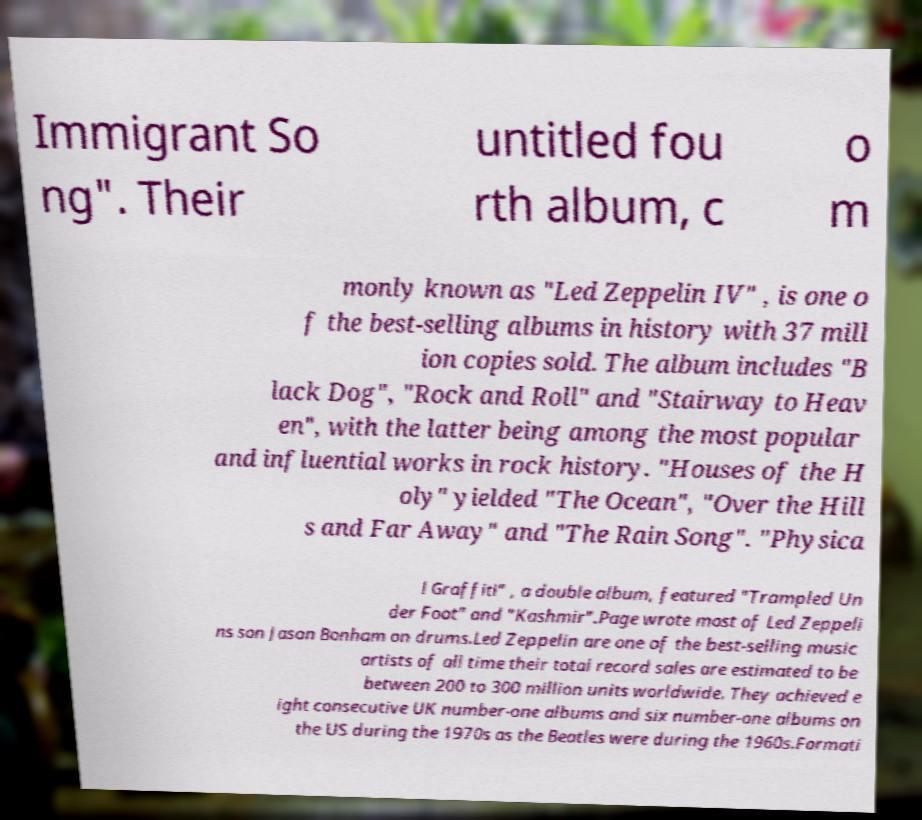There's text embedded in this image that I need extracted. Can you transcribe it verbatim? Immigrant So ng". Their untitled fou rth album, c o m monly known as "Led Zeppelin IV" , is one o f the best-selling albums in history with 37 mill ion copies sold. The album includes "B lack Dog", "Rock and Roll" and "Stairway to Heav en", with the latter being among the most popular and influential works in rock history. "Houses of the H oly" yielded "The Ocean", "Over the Hill s and Far Away" and "The Rain Song". "Physica l Graffiti" , a double album, featured "Trampled Un der Foot" and "Kashmir".Page wrote most of Led Zeppeli ns son Jason Bonham on drums.Led Zeppelin are one of the best-selling music artists of all time their total record sales are estimated to be between 200 to 300 million units worldwide. They achieved e ight consecutive UK number-one albums and six number-one albums on the US during the 1970s as the Beatles were during the 1960s.Formati 